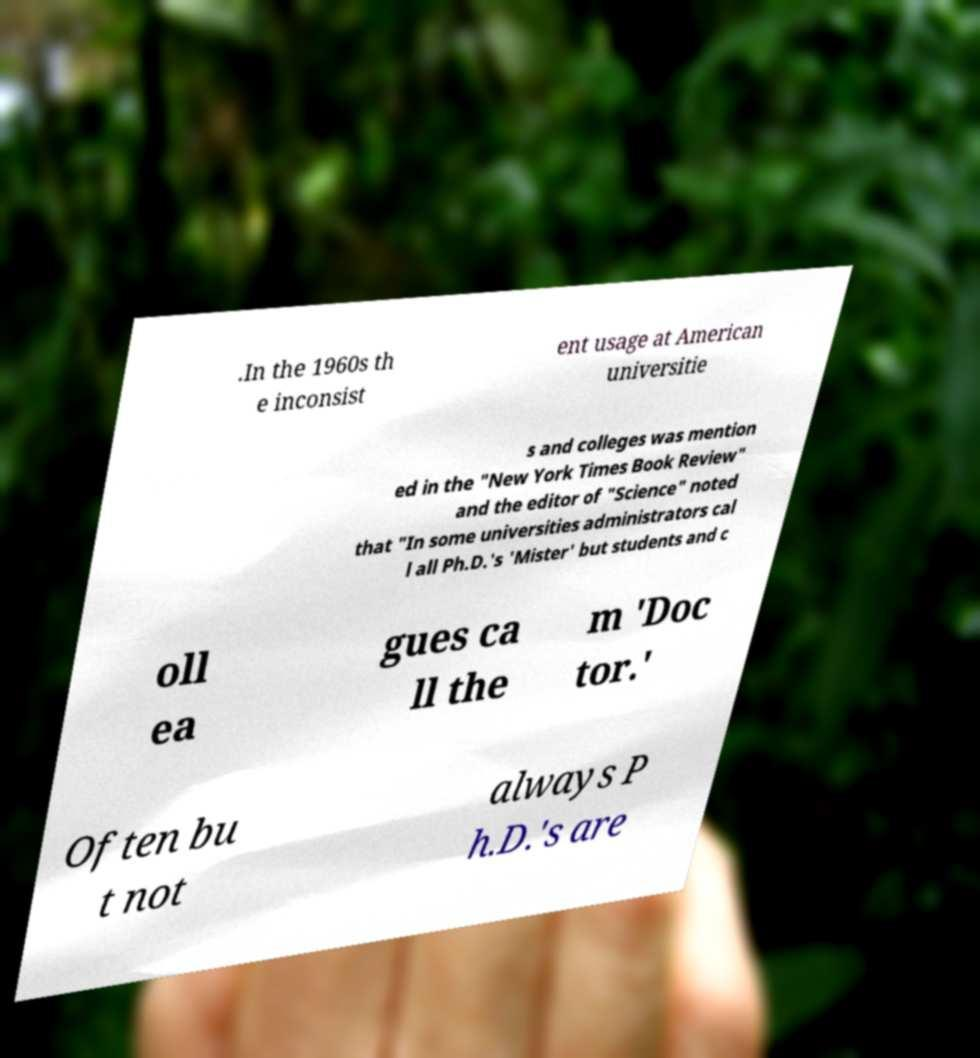There's text embedded in this image that I need extracted. Can you transcribe it verbatim? .In the 1960s th e inconsist ent usage at American universitie s and colleges was mention ed in the "New York Times Book Review" and the editor of "Science" noted that "In some universities administrators cal l all Ph.D.'s 'Mister' but students and c oll ea gues ca ll the m 'Doc tor.' Often bu t not always P h.D.'s are 